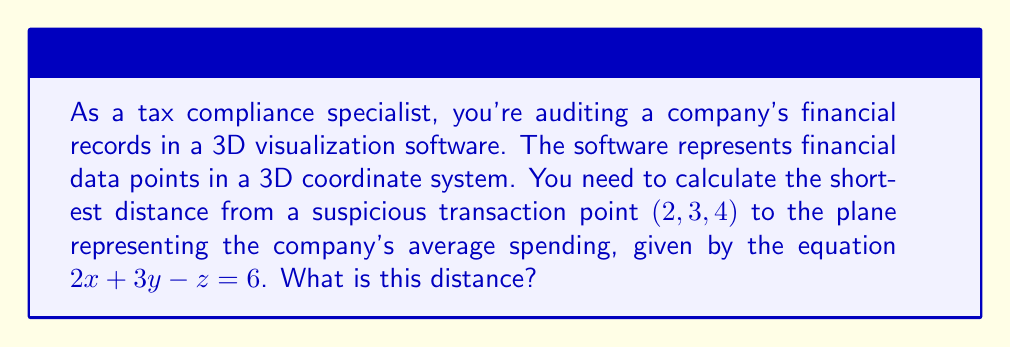Can you solve this math problem? To find the distance from a point to a plane in 3D space, we'll use the formula:

$$d = \frac{|Ax_0 + By_0 + Cz_0 + D|}{\sqrt{A^2 + B^2 + C^2}}$$

Where $(x_0, y_0, z_0)$ is the point, and $Ax + By + Cz + D = 0$ is the equation of the plane.

Step 1: Identify the components from the given information:
- Point: $(x_0, y_0, z_0) = (2, 3, 4)$
- Plane equation: $2x + 3y - z = 6$, which we rewrite as $2x + 3y - z - 6 = 0$

So, $A = 2$, $B = 3$, $C = -1$, and $D = -6$

Step 2: Substitute into the distance formula:

$$d = \frac{|2(2) + 3(3) + (-1)(4) + (-6)|}{\sqrt{2^2 + 3^2 + (-1)^2}}$$

Step 3: Simplify the numerator:
$$d = \frac{|4 + 9 - 4 - 6|}{\sqrt{4 + 9 + 1}}$$
$$d = \frac{|3|}{\sqrt{14}}$$

Step 4: Simplify the fraction:
$$d = \frac{3}{\sqrt{14}}$$

This is our final answer, but we can also express it as a decimal:

$$d \approx 0.8018$$
Answer: $\frac{3}{\sqrt{14}}$ or approximately $0.8018$ 